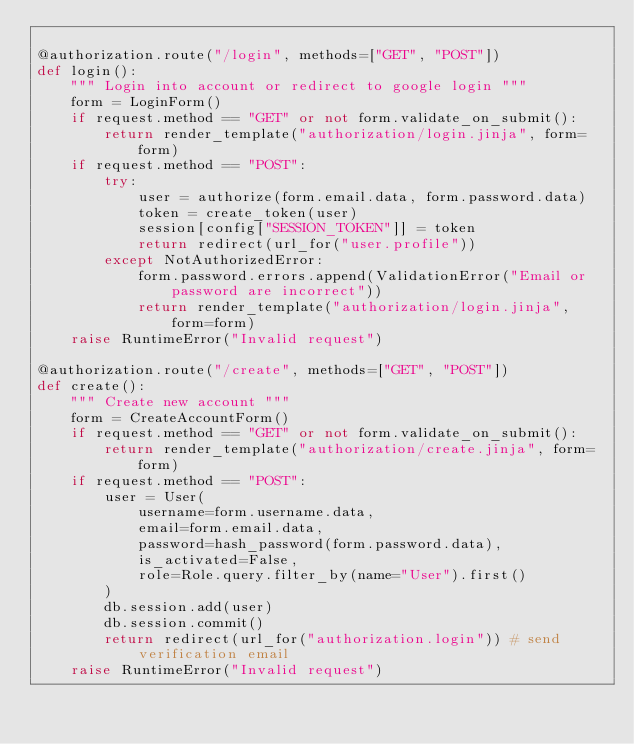Convert code to text. <code><loc_0><loc_0><loc_500><loc_500><_Python_>
@authorization.route("/login", methods=["GET", "POST"])
def login():
    """ Login into account or redirect to google login """
    form = LoginForm()
    if request.method == "GET" or not form.validate_on_submit():
        return render_template("authorization/login.jinja", form=form)
    if request.method == "POST":
        try:
            user = authorize(form.email.data, form.password.data)
            token = create_token(user)
            session[config["SESSION_TOKEN"]] = token
            return redirect(url_for("user.profile"))
        except NotAuthorizedError:
            form.password.errors.append(ValidationError("Email or password are incorrect"))
            return render_template("authorization/login.jinja", form=form)
    raise RuntimeError("Invalid request")

@authorization.route("/create", methods=["GET", "POST"])
def create():
    """ Create new account """
    form = CreateAccountForm()
    if request.method == "GET" or not form.validate_on_submit():
        return render_template("authorization/create.jinja", form=form)
    if request.method == "POST":
        user = User(
            username=form.username.data,
            email=form.email.data,
            password=hash_password(form.password.data),
            is_activated=False,
            role=Role.query.filter_by(name="User").first()
        )
        db.session.add(user)
        db.session.commit()
        return redirect(url_for("authorization.login")) # send verification email
    raise RuntimeError("Invalid request")
</code> 